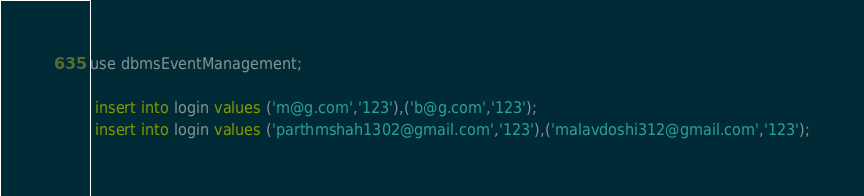<code> <loc_0><loc_0><loc_500><loc_500><_SQL_>use dbmsEventManagement;

 insert into login values ('m@g.com','123'),('b@g.com','123');
 insert into login values ('parthmshah1302@gmail.com','123'),('malavdoshi312@gmail.com','123');
</code> 